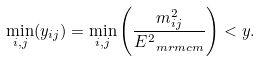Convert formula to latex. <formula><loc_0><loc_0><loc_500><loc_500>\min _ { i , j } ( y _ { i j } ) = \min _ { i , j } \left ( \frac { m _ { i j } ^ { 2 } } { E _ { \ m r m { c m } } ^ { 2 } } \right ) < y .</formula> 